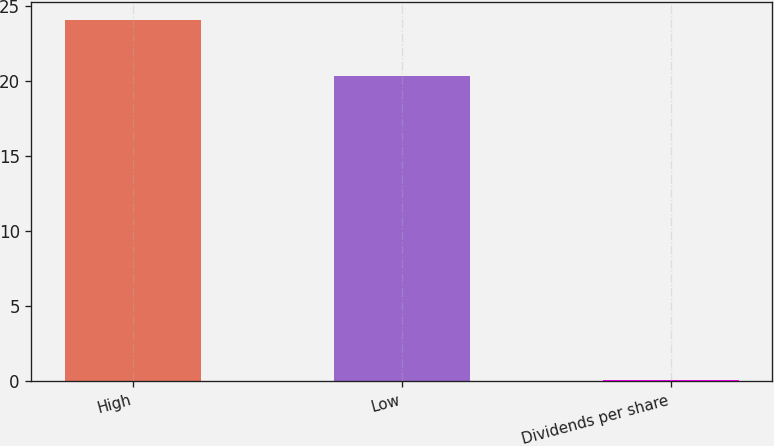<chart> <loc_0><loc_0><loc_500><loc_500><bar_chart><fcel>High<fcel>Low<fcel>Dividends per share<nl><fcel>24.06<fcel>20.38<fcel>0.08<nl></chart> 